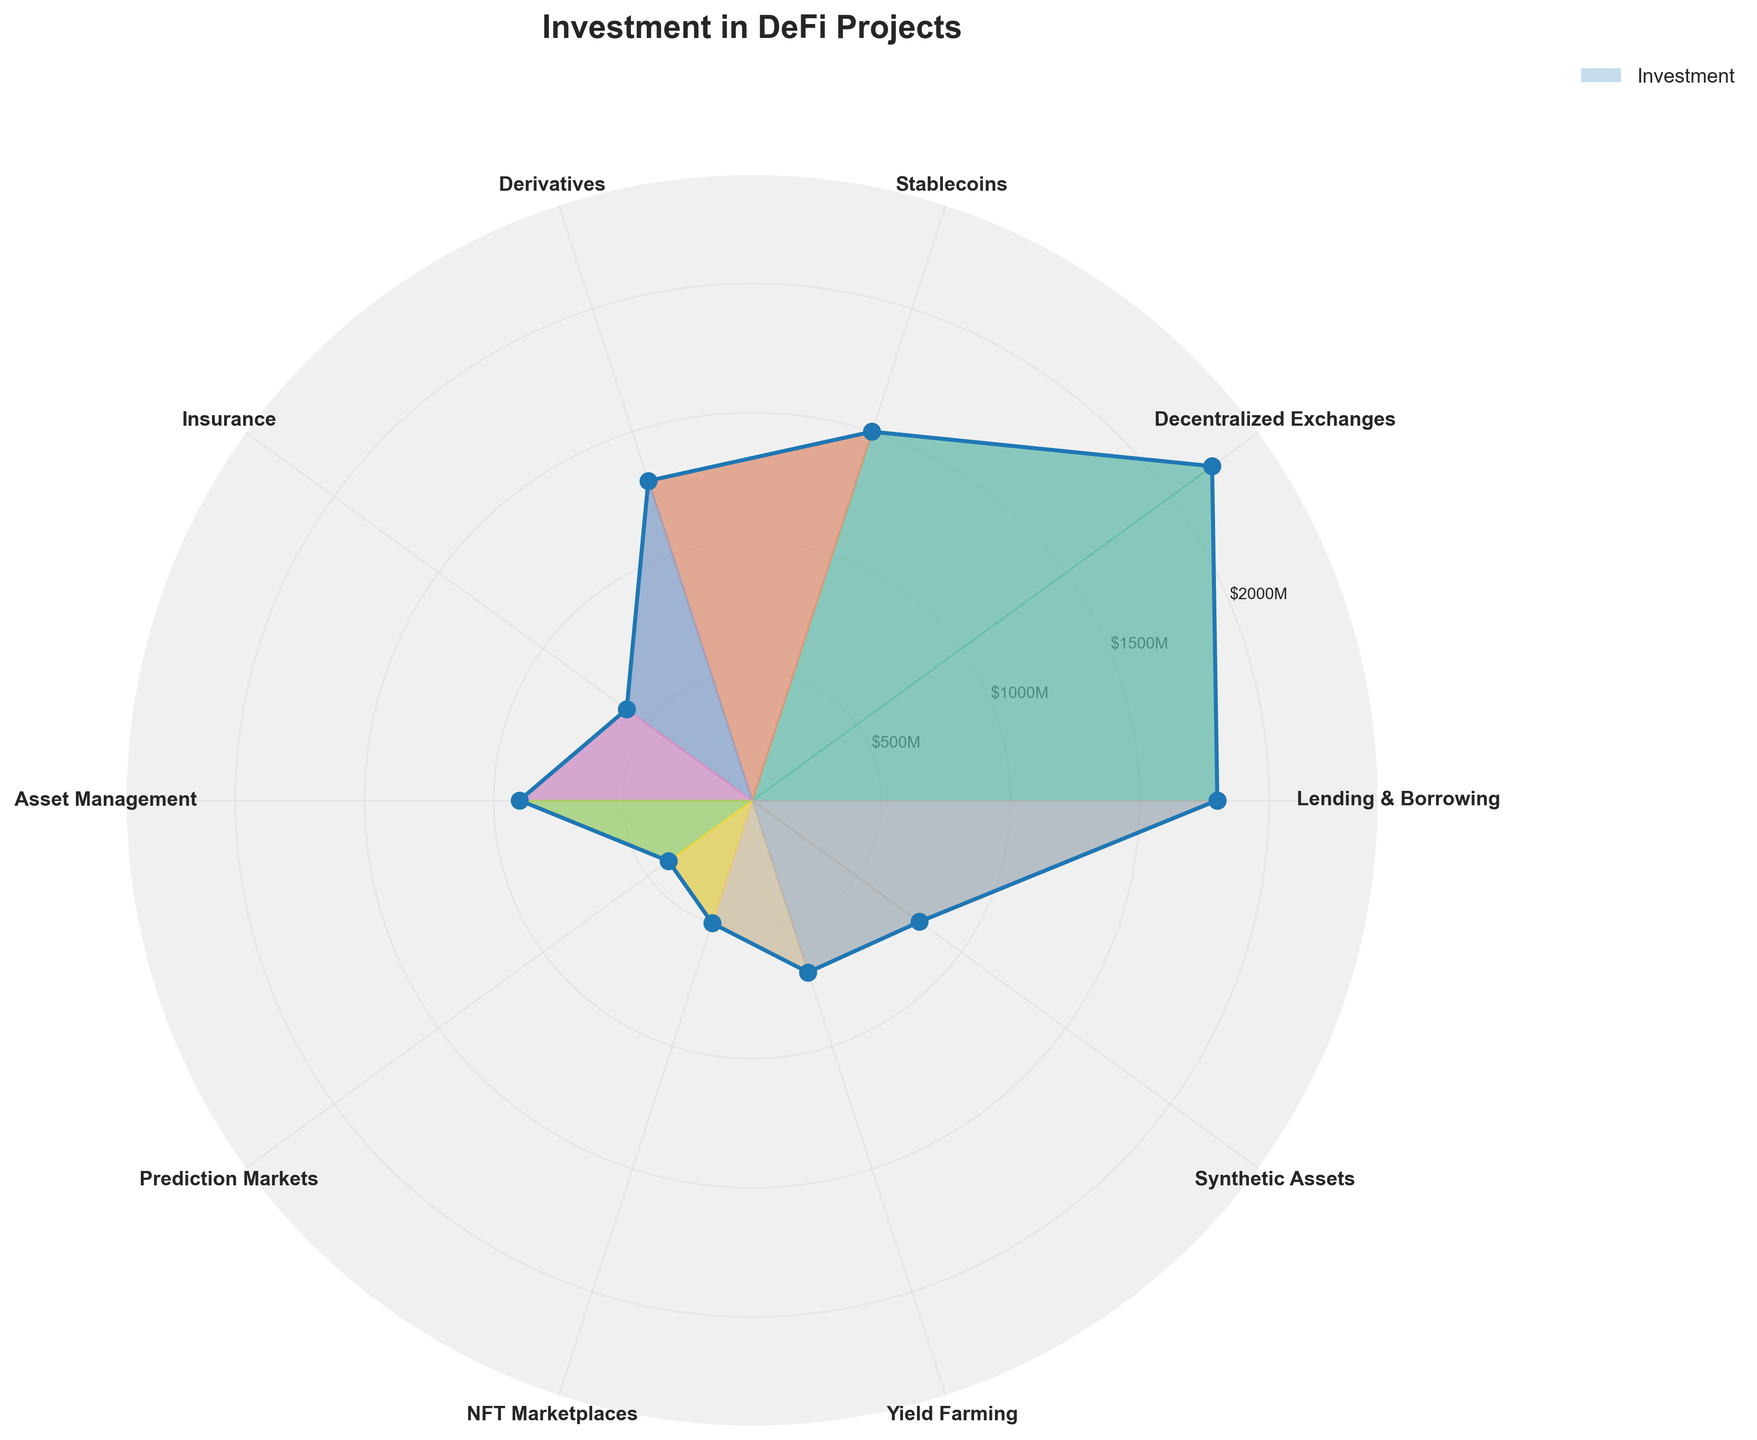What is the title of the chart? The title of the chart is displayed at the top center and reads "Investment in DeFi Projects".
Answer: Investment in DeFi Projects Which category has the highest investment amount? By looking at the height of the filled area corresponding to each segment in the polar area chart, the "Decentralized Exchanges" category has the highest investment amount.
Answer: Decentralized Exchanges How much is the investment in the Lending & Borrowing category? The segment corresponding to "Lending & Borrowing" extends to the value labeled around 1800 on the radial axis, indicating its investment amount is 1800 million USD.
Answer: 1800 million USD How much more investment is there in Decentralized Exchanges compared to NFT Marketplaces? The investment in Decentralized Exchanges is 2200 million USD and in NFT Marketplaces is 500 million USD. The difference is 2200 - 500 = 1700 million USD.
Answer: 1700 million USD What is the combined investment in Predictive Markets and Yield Farming? The investment in Predictive Markets is 400 million USD, and in Yield Farming is 700 million USD. Their combined investment is 400 + 700 = 1100 million USD.
Answer: 1100 million USD Which categories have investments less than 1000 million USD? From the chart, the segments for Insurance (600), Asset Management (900), Prediction Markets (400), NFT Marketplaces (500), Yield Farming (700), and Synthetic Assets (800) are below the 1000 million USD line.
Answer: Insurance, Asset Management, Prediction Markets, NFT Marketplaces, Yield Farming, Synthetic Assets What is the average investment amount across all categories? Sum of investments = 1800 + 2200 + 1500 + 1300 + 600 + 900 + 400 + 500 + 700 + 800 = 10700 million USD. Number of categories = 10. Average investment = 10700 / 10 = 1070 million USD.
Answer: 1070 million USD Is the investment in Stablecoins higher than in Derivatives? By comparing the segment lengths, Stablecoins (1500 million USD) have a higher investment than Derivatives (1300 million USD).
Answer: Yes Describe the color-coding used in the chart. Each category segment is filled with a different color from a varied palette, visually distinguishing them. This helps in easily identifying and comparing investment amounts across different categories.
Answer: Varying colors 